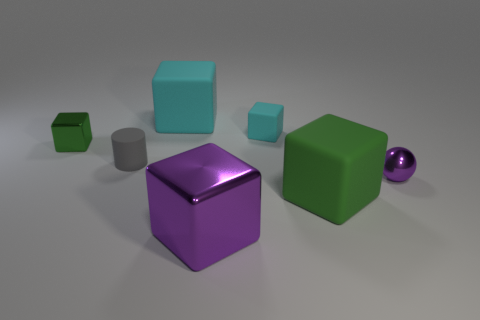The rubber thing that is the same color as the small matte cube is what shape?
Your answer should be very brief. Cube. What is the material of the tiny cube behind the green thing that is to the left of the green cube that is to the right of the large cyan rubber object?
Make the answer very short. Rubber. There is another purple thing that is made of the same material as the tiny purple object; what size is it?
Make the answer very short. Large. Is there a matte thing of the same color as the rubber cylinder?
Give a very brief answer. No. Does the gray cylinder have the same size as the green matte thing that is behind the purple shiny cube?
Make the answer very short. No. How many green matte things are behind the big object that is behind the matte cube that is in front of the green metal cube?
Provide a short and direct response. 0. What is the size of the object that is the same color as the tiny metal cube?
Offer a terse response. Large. Are there any large metallic cubes behind the green metal cube?
Your answer should be very brief. No. What is the shape of the large green matte thing?
Offer a terse response. Cube. There is a cyan matte object that is right of the cyan rubber object on the left side of the purple metallic object on the left side of the purple sphere; what shape is it?
Make the answer very short. Cube. 